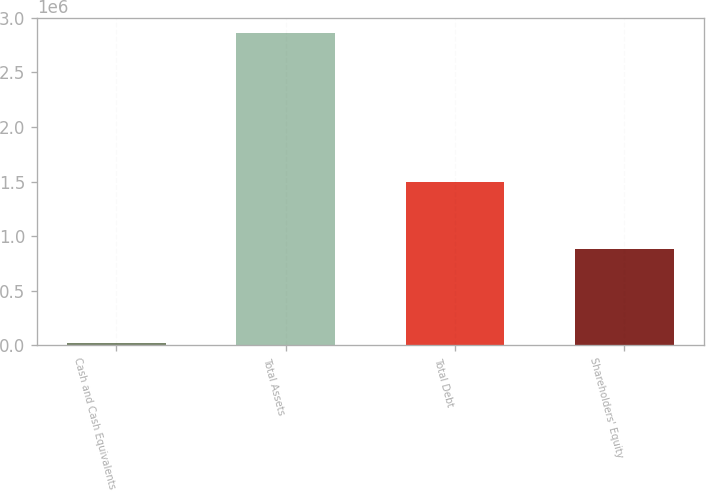Convert chart. <chart><loc_0><loc_0><loc_500><loc_500><bar_chart><fcel>Cash and Cash Equivalents<fcel>Total Assets<fcel>Total Debt<fcel>Shareholders' Equity<nl><fcel>21359<fcel>2.85991e+06<fcel>1.4961e+06<fcel>885959<nl></chart> 